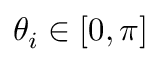Convert formula to latex. <formula><loc_0><loc_0><loc_500><loc_500>\theta _ { i } \in [ 0 , \pi ]</formula> 